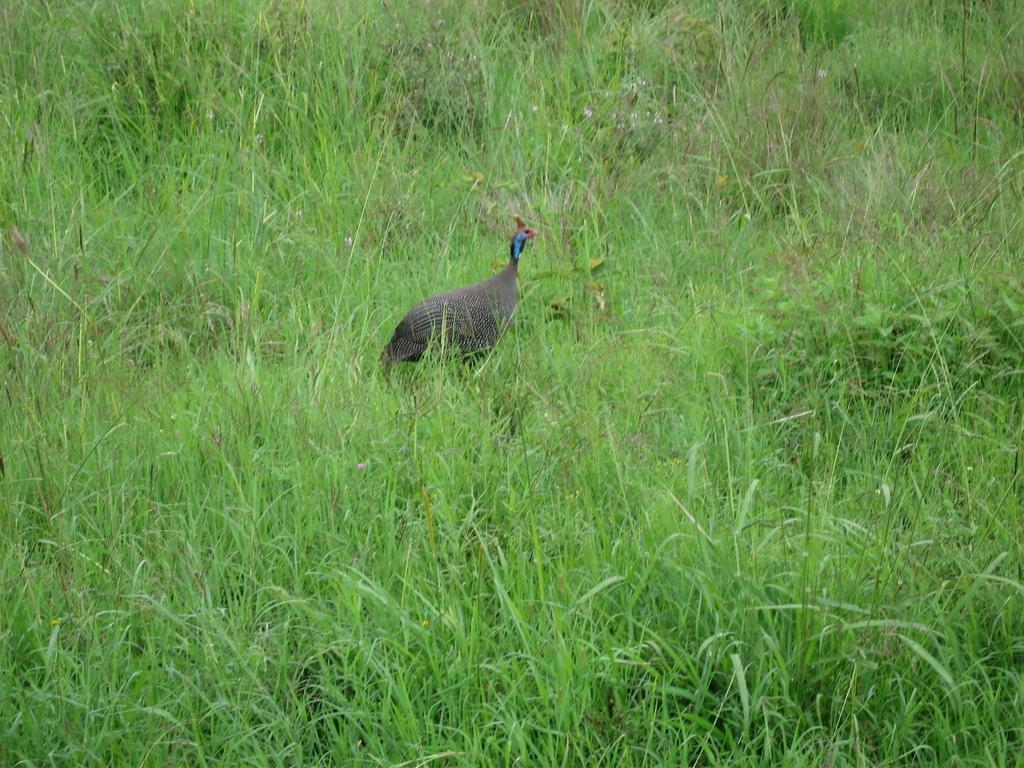What type of animal is in the image? There is a bird in the image. What colors can be seen on the bird? The bird has black, white, blue, and red colors. Where is the bird located in the image? The bird is standing on the ground. What type of vegetation is present on the ground in the image? There is grass on the ground in the image. What type of pickle is the bird holding in its beak in the image? There is no pickle present in the image; the bird is not holding anything in its beak. 